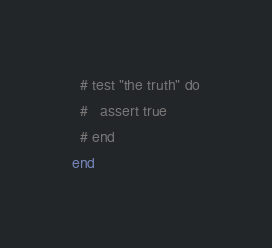Convert code to text. <code><loc_0><loc_0><loc_500><loc_500><_Ruby_>  # test "the truth" do
  #   assert true
  # end
end
</code> 